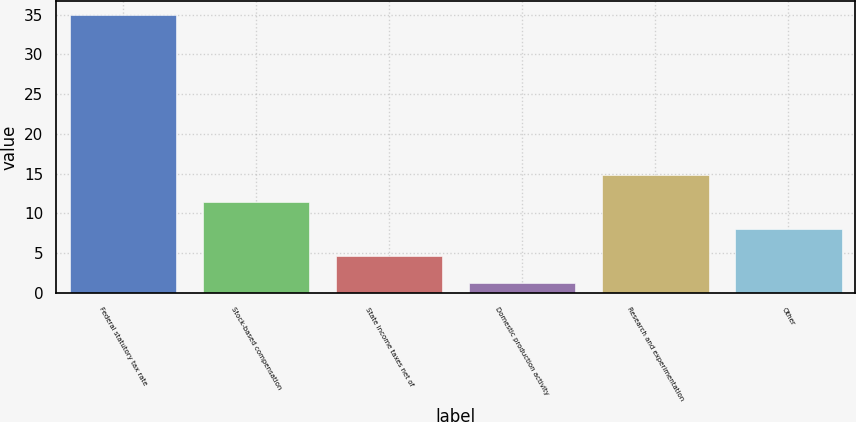<chart> <loc_0><loc_0><loc_500><loc_500><bar_chart><fcel>Federal statutory tax rate<fcel>Stock-based compensation<fcel>State income taxes net of<fcel>Domestic production activity<fcel>Research and experimentation<fcel>Other<nl><fcel>35<fcel>11.41<fcel>4.67<fcel>1.3<fcel>14.78<fcel>8.04<nl></chart> 